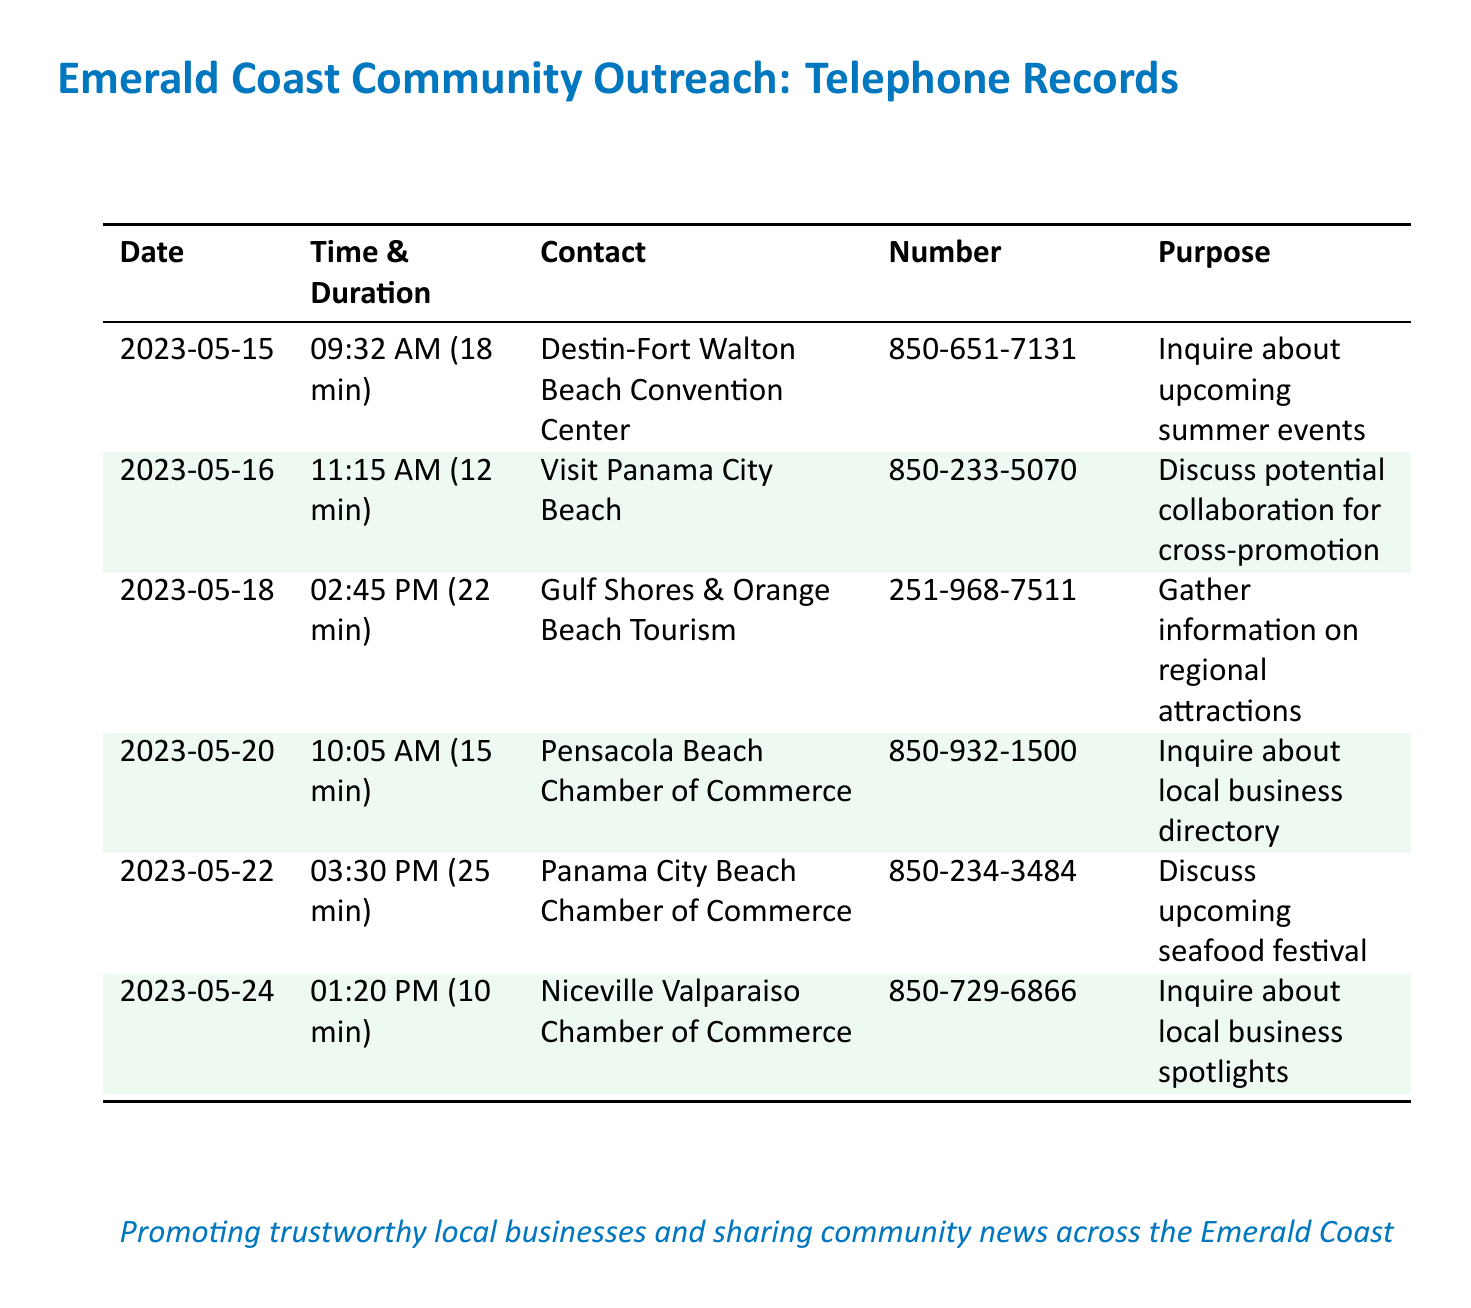what is the date of the call to Destin-Fort Walton Beach Convention Center? The date of the call can be found under the Date column in the document.
Answer: 2023-05-15 how long was the call with Panama City Beach Chamber of Commerce? The duration of the call is specified in the Time & Duration column for that contact.
Answer: 25 min what is the purpose of the call to Gulf Shores & Orange Beach Tourism? The purpose is described in the Purpose column for the corresponding contact.
Answer: Gather information on regional attractions how many calls were made on May 20? The document lists one entry for that date, indicating only one call was made.
Answer: 1 which organization was contacted at 850-729-6866? The number can be matched to the organization in the Contact column to find the name.
Answer: Niceville Valparaiso Chamber of Commerce which local business was discussed in the May 22 call? The document states the purpose of that call in the Purpose column to identify the business discussed.
Answer: Upcoming seafood festival what was the total duration of all calls made to tourism boards? This requires summing the individual durations listed in the Time & Duration column for the relevant contacts.
Answer: 92 min how many different organizations were contacted in total? By counting the unique entries in the Contact column, we can determine the number of organizations.
Answer: 6 what color is used for the row heading in the table? The color refers to the visual design specified for the row colors in the document.
Answer: Emerald green 